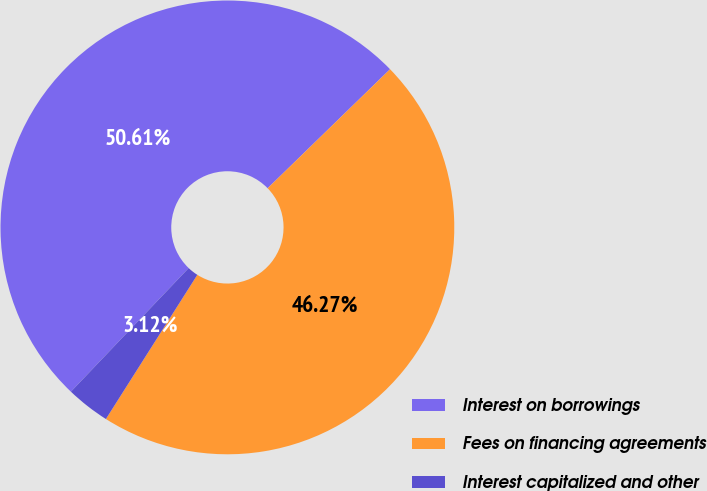<chart> <loc_0><loc_0><loc_500><loc_500><pie_chart><fcel>Interest on borrowings<fcel>Fees on financing agreements<fcel>Interest capitalized and other<nl><fcel>50.61%<fcel>46.27%<fcel>3.12%<nl></chart> 